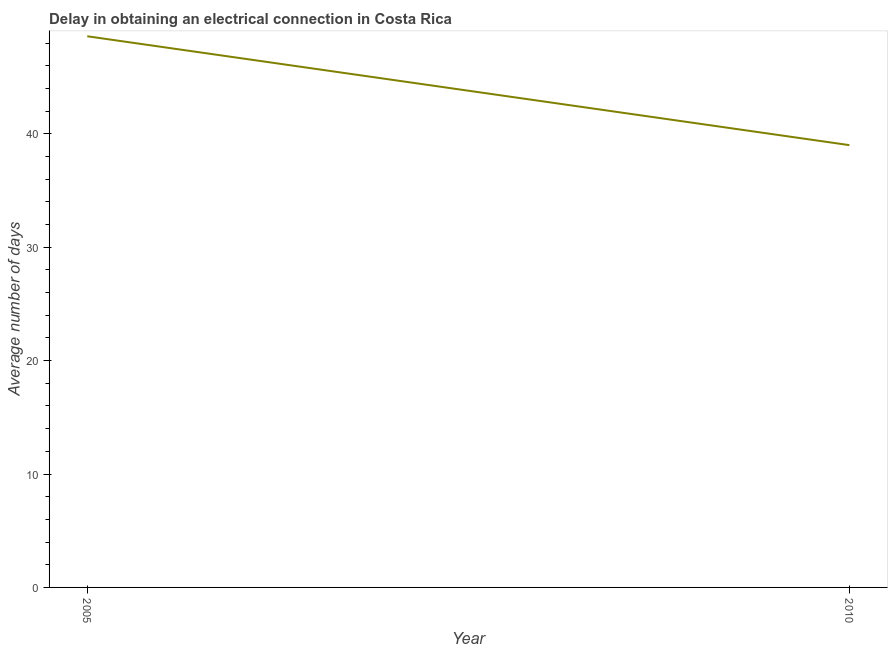Across all years, what is the maximum dalay in electrical connection?
Ensure brevity in your answer.  48.6. Across all years, what is the minimum dalay in electrical connection?
Provide a succinct answer. 39. In which year was the dalay in electrical connection maximum?
Keep it short and to the point. 2005. In which year was the dalay in electrical connection minimum?
Your answer should be compact. 2010. What is the sum of the dalay in electrical connection?
Give a very brief answer. 87.6. What is the difference between the dalay in electrical connection in 2005 and 2010?
Provide a succinct answer. 9.6. What is the average dalay in electrical connection per year?
Your answer should be compact. 43.8. What is the median dalay in electrical connection?
Your response must be concise. 43.8. Do a majority of the years between 2010 and 2005 (inclusive) have dalay in electrical connection greater than 32 days?
Your response must be concise. No. What is the ratio of the dalay in electrical connection in 2005 to that in 2010?
Provide a short and direct response. 1.25. Does the dalay in electrical connection monotonically increase over the years?
Your answer should be compact. No. How many lines are there?
Keep it short and to the point. 1. How many years are there in the graph?
Give a very brief answer. 2. What is the difference between two consecutive major ticks on the Y-axis?
Provide a succinct answer. 10. Does the graph contain grids?
Give a very brief answer. No. What is the title of the graph?
Your answer should be compact. Delay in obtaining an electrical connection in Costa Rica. What is the label or title of the X-axis?
Your answer should be very brief. Year. What is the label or title of the Y-axis?
Give a very brief answer. Average number of days. What is the Average number of days of 2005?
Provide a succinct answer. 48.6. What is the ratio of the Average number of days in 2005 to that in 2010?
Your response must be concise. 1.25. 